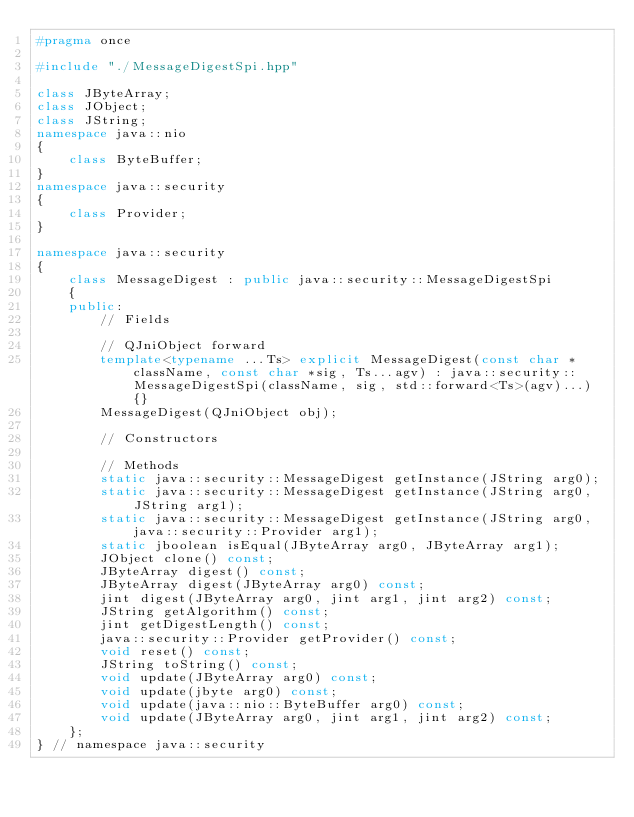<code> <loc_0><loc_0><loc_500><loc_500><_C++_>#pragma once

#include "./MessageDigestSpi.hpp"

class JByteArray;
class JObject;
class JString;
namespace java::nio
{
	class ByteBuffer;
}
namespace java::security
{
	class Provider;
}

namespace java::security
{
	class MessageDigest : public java::security::MessageDigestSpi
	{
	public:
		// Fields
		
		// QJniObject forward
		template<typename ...Ts> explicit MessageDigest(const char *className, const char *sig, Ts...agv) : java::security::MessageDigestSpi(className, sig, std::forward<Ts>(agv)...) {}
		MessageDigest(QJniObject obj);
		
		// Constructors
		
		// Methods
		static java::security::MessageDigest getInstance(JString arg0);
		static java::security::MessageDigest getInstance(JString arg0, JString arg1);
		static java::security::MessageDigest getInstance(JString arg0, java::security::Provider arg1);
		static jboolean isEqual(JByteArray arg0, JByteArray arg1);
		JObject clone() const;
		JByteArray digest() const;
		JByteArray digest(JByteArray arg0) const;
		jint digest(JByteArray arg0, jint arg1, jint arg2) const;
		JString getAlgorithm() const;
		jint getDigestLength() const;
		java::security::Provider getProvider() const;
		void reset() const;
		JString toString() const;
		void update(JByteArray arg0) const;
		void update(jbyte arg0) const;
		void update(java::nio::ByteBuffer arg0) const;
		void update(JByteArray arg0, jint arg1, jint arg2) const;
	};
} // namespace java::security

</code> 